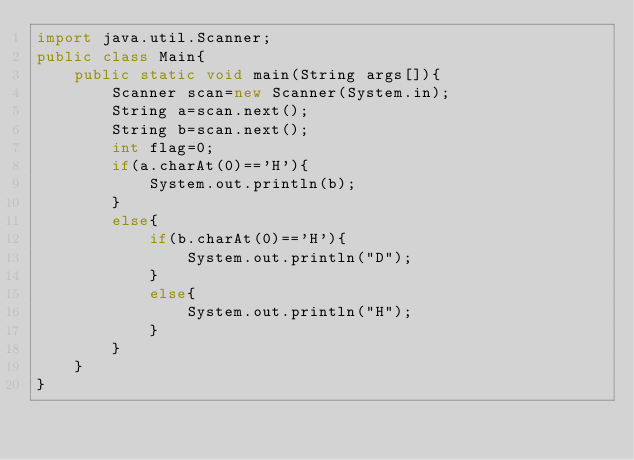<code> <loc_0><loc_0><loc_500><loc_500><_Java_>import java.util.Scanner;
public class Main{
    public static void main(String args[]){
        Scanner scan=new Scanner(System.in);
        String a=scan.next();
        String b=scan.next();
        int flag=0;
        if(a.charAt(0)=='H'){
            System.out.println(b);
        }
        else{
            if(b.charAt(0)=='H'){
                System.out.println("D");
            }
            else{
                System.out.println("H");
            }
        }
    }
}</code> 